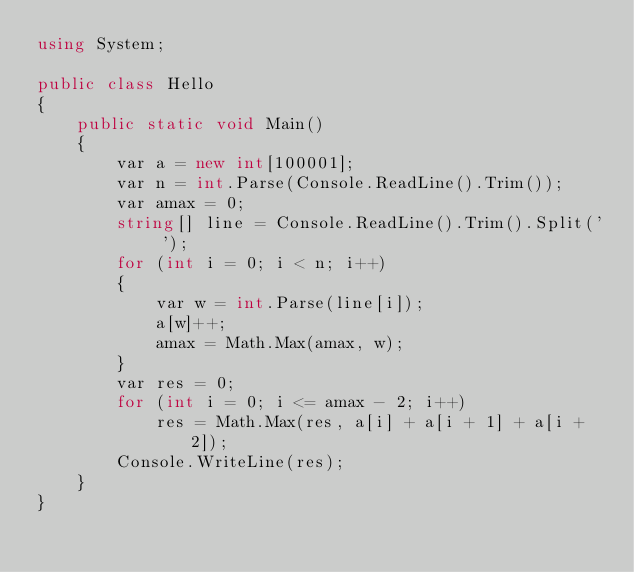<code> <loc_0><loc_0><loc_500><loc_500><_C#_>using System;

public class Hello
{
    public static void Main()
    {
        var a = new int[100001];
        var n = int.Parse(Console.ReadLine().Trim());
        var amax = 0;
        string[] line = Console.ReadLine().Trim().Split(' ');
        for (int i = 0; i < n; i++)
        {
            var w = int.Parse(line[i]);
            a[w]++;
            amax = Math.Max(amax, w);
        }
        var res = 0;
        for (int i = 0; i <= amax - 2; i++)
            res = Math.Max(res, a[i] + a[i + 1] + a[i + 2]);
        Console.WriteLine(res);
    }
}</code> 